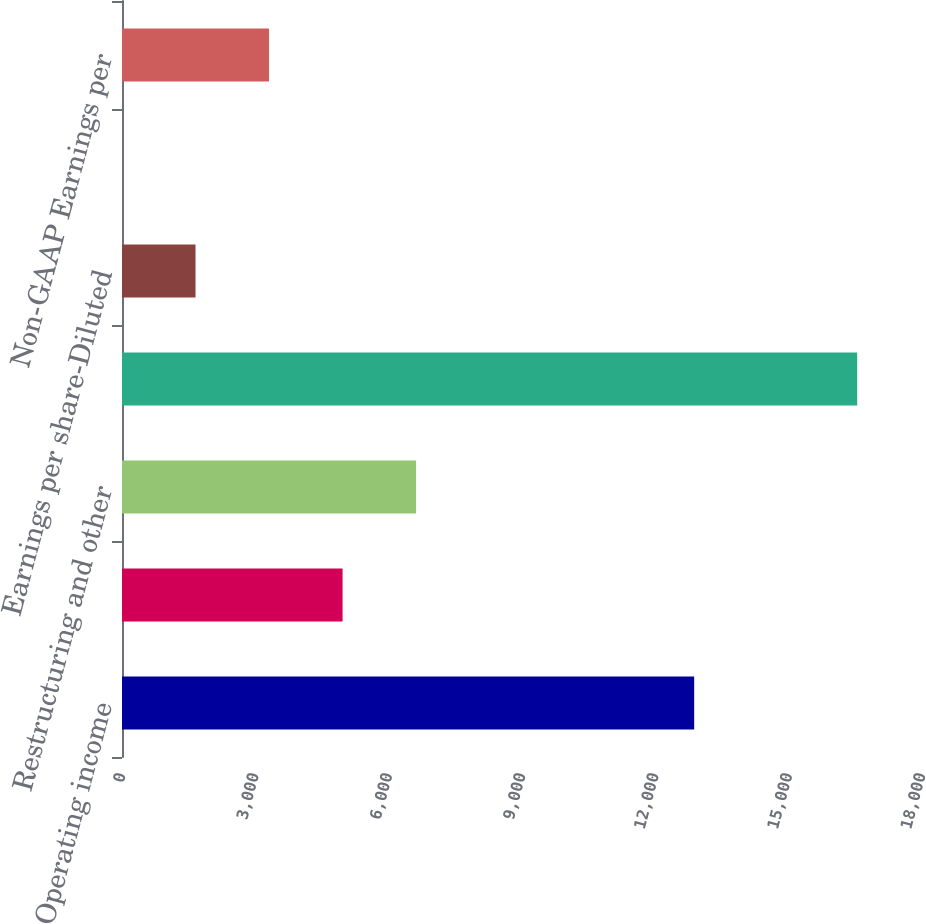Convert chart to OTSL. <chart><loc_0><loc_0><loc_500><loc_500><bar_chart><fcel>Operating income<fcel>Amortization of<fcel>Restructuring and other<fcel>Non-GAAP operating income<fcel>Earnings per share-Diluted<fcel>Income tax effect<fcel>Non-GAAP Earnings per<nl><fcel>12874<fcel>4962.7<fcel>6616.89<fcel>16542<fcel>1654.34<fcel>0.15<fcel>3308.52<nl></chart> 